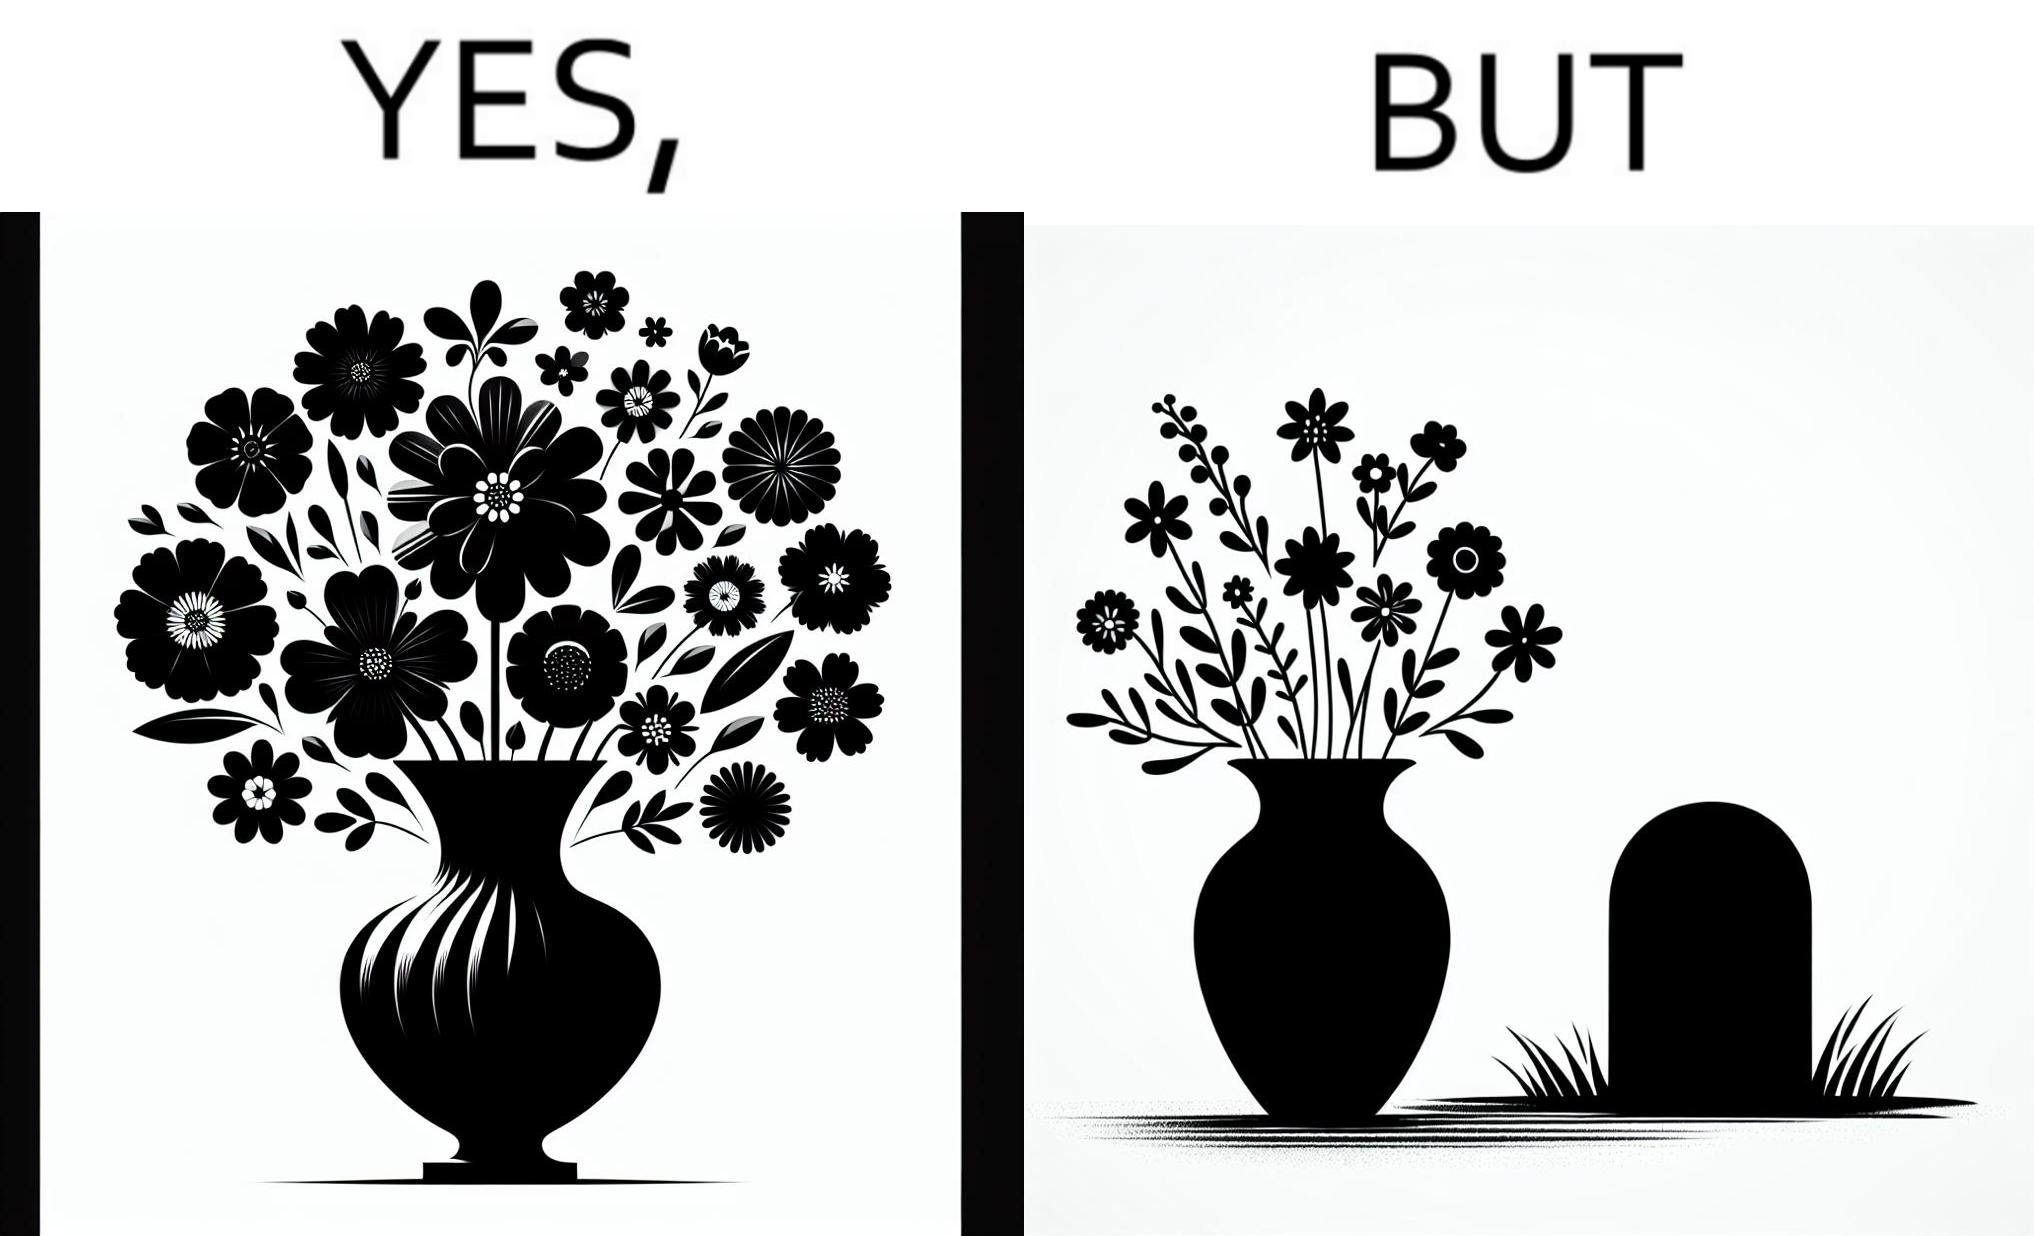Why is this image considered satirical? The image is ironic, because in the first image a vase full of different beautiful flowers is seen which spreads a feeling of positivity, cheerfulness etc., whereas in the second image when the same vase is put in front of a grave stone it produces a feeling of sorrow 